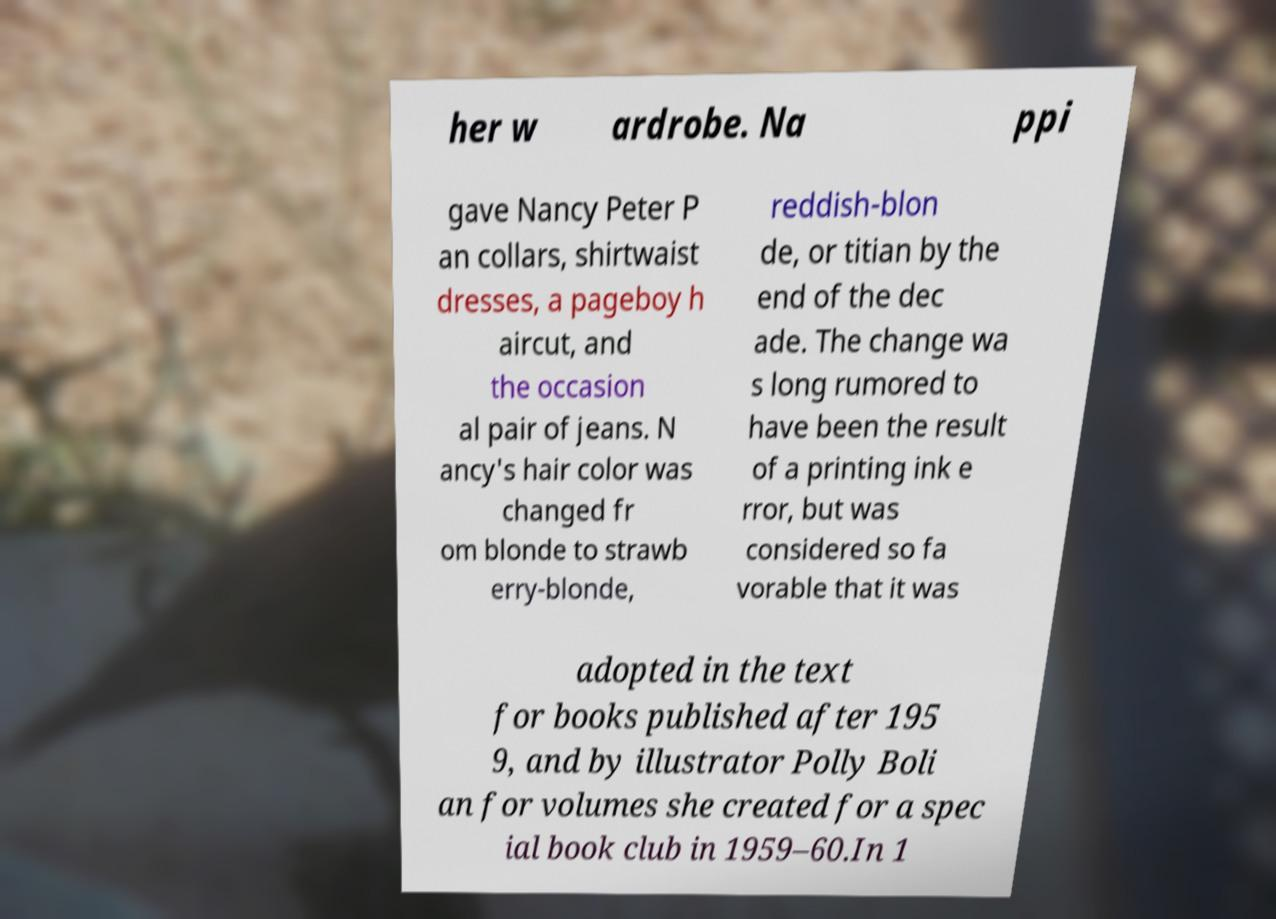Could you extract and type out the text from this image? her w ardrobe. Na ppi gave Nancy Peter P an collars, shirtwaist dresses, a pageboy h aircut, and the occasion al pair of jeans. N ancy's hair color was changed fr om blonde to strawb erry-blonde, reddish-blon de, or titian by the end of the dec ade. The change wa s long rumored to have been the result of a printing ink e rror, but was considered so fa vorable that it was adopted in the text for books published after 195 9, and by illustrator Polly Boli an for volumes she created for a spec ial book club in 1959–60.In 1 